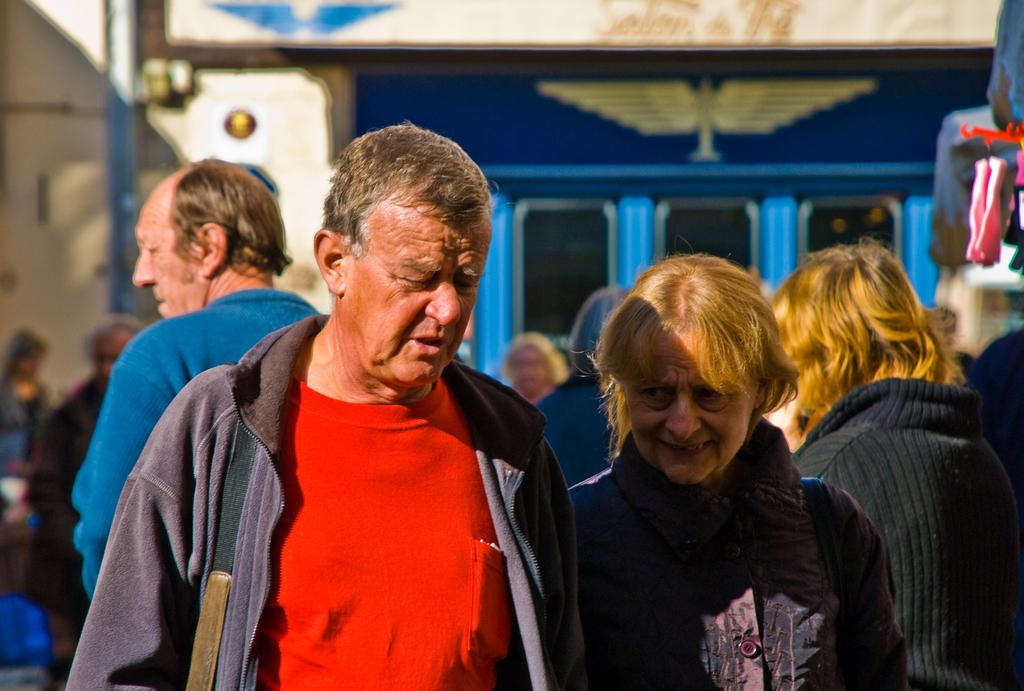How many people are in the image? There is a group of people in the image. What can be seen in the background of the image? There is a building in the background of the image. What is on the building? There is a board on the building. What is written or displayed on the board? There is text on the board. What else can be seen in the image besides the people and the building? There appears to be a pole in the image. What type of meal is being served in the image? There is no meal present in the image; it features a group of people, a building, a board, text, and a pole. 